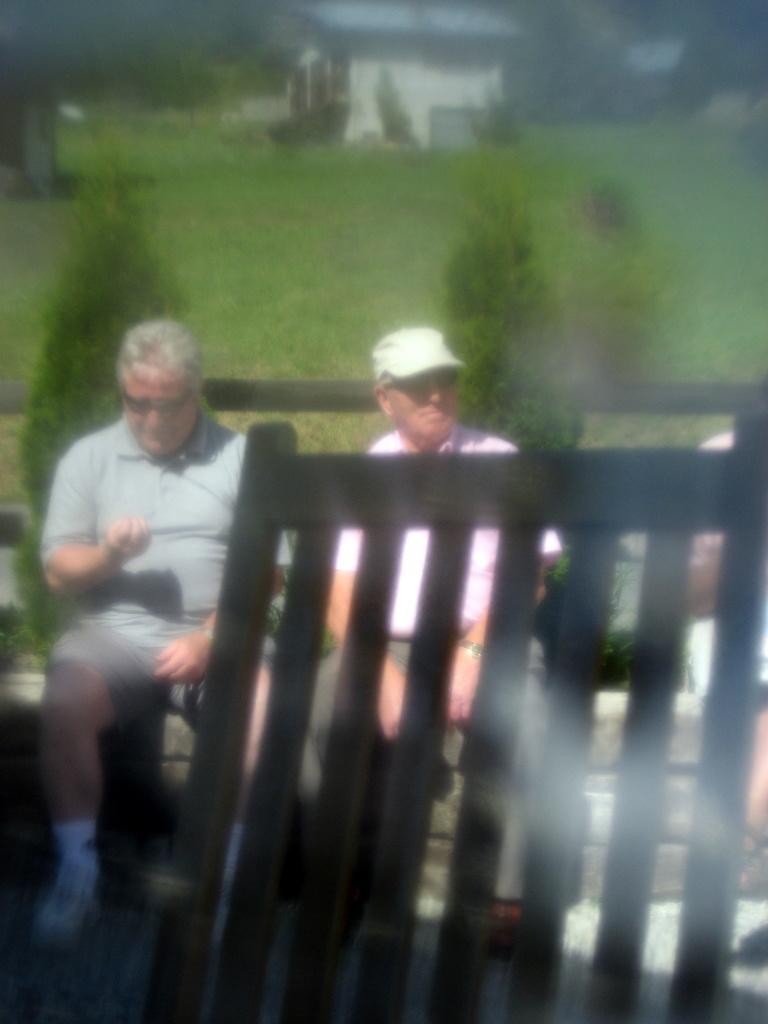Can you describe this image briefly? In this image in the front there is a wooden stand. In the center there are persons sitting, there are plants and there is a railing. In the background there is grass on the ground and there is a house and there are trees. 